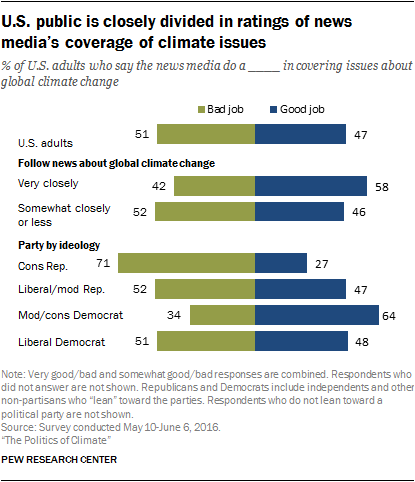Highlight a few significant elements in this photo. The result of taking the sum of the two smallest green bars and smallest blue bars and deducting the smaller value from the larger value is 3. The two bars in the chart represent the categorization of a "Bad Job" and a "Good Job". 